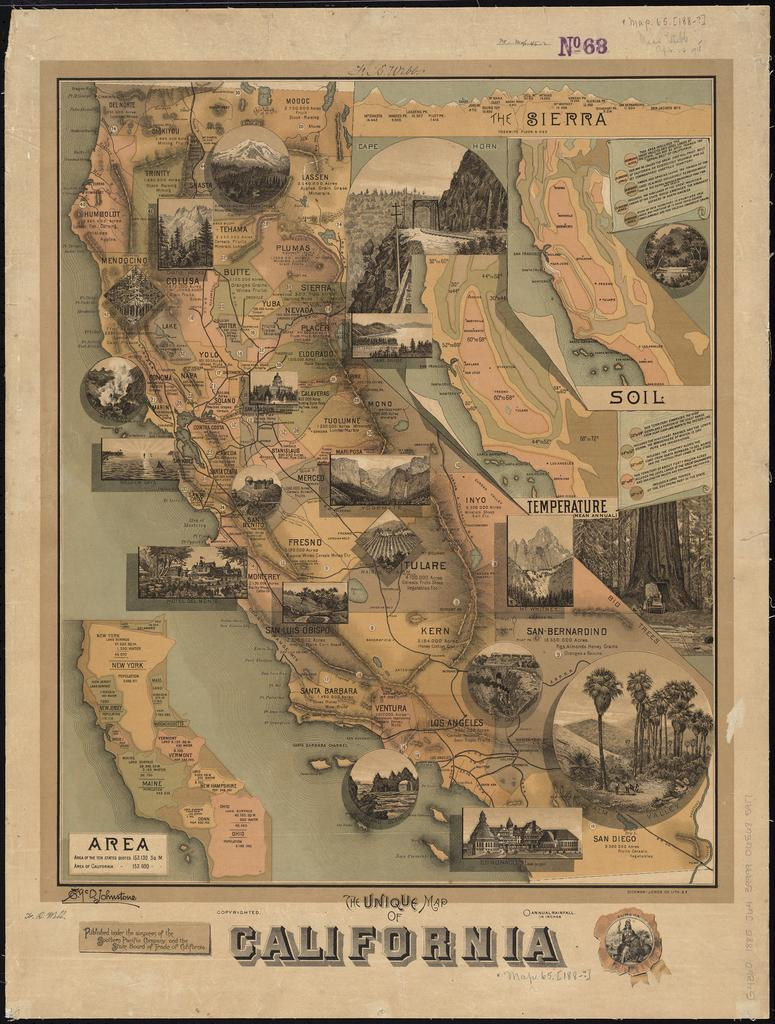<image>
Relay a brief, clear account of the picture shown. Map of California with the number 68 on top in purple. 